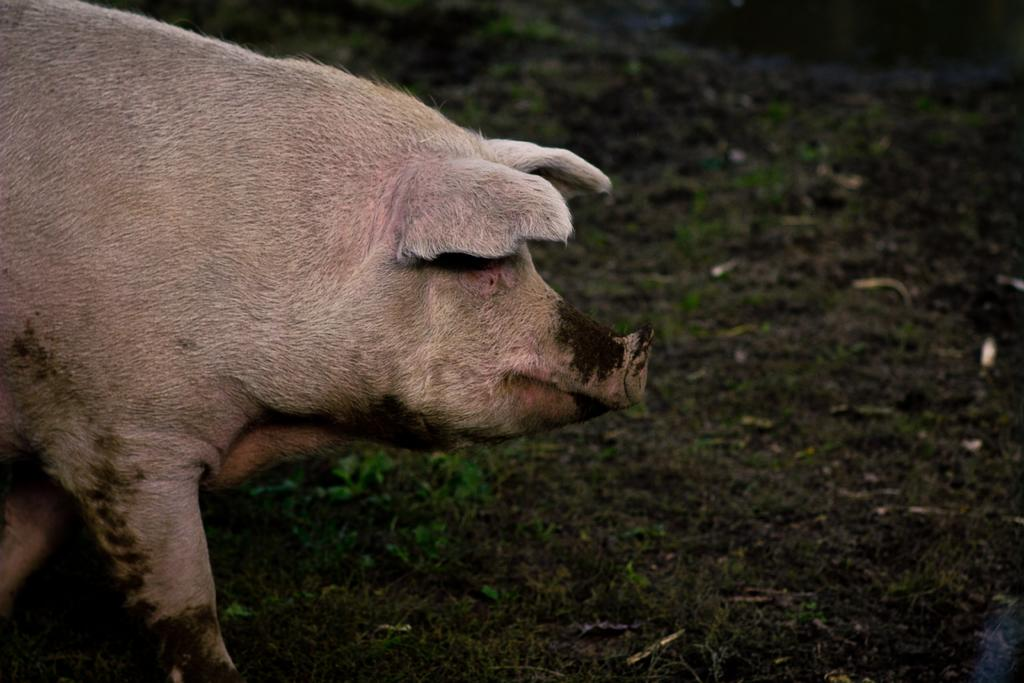What animal is present in the image? There is a pig in the image. What is the pig doing in the image? The pig is standing on the ground. What type of vessel is being used to catch the pig in the image? There is no vessel present in the image, and the pig is not being caught. 